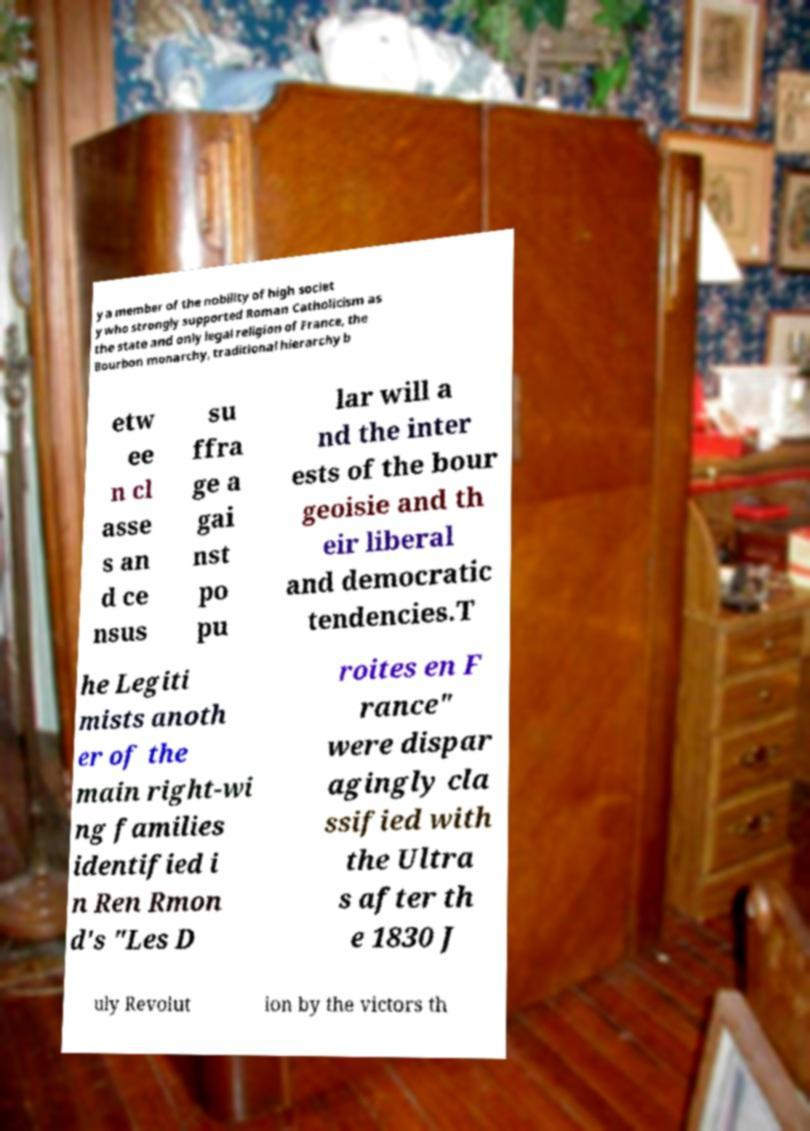Can you accurately transcribe the text from the provided image for me? y a member of the nobility of high societ y who strongly supported Roman Catholicism as the state and only legal religion of France, the Bourbon monarchy, traditional hierarchy b etw ee n cl asse s an d ce nsus su ffra ge a gai nst po pu lar will a nd the inter ests of the bour geoisie and th eir liberal and democratic tendencies.T he Legiti mists anoth er of the main right-wi ng families identified i n Ren Rmon d's "Les D roites en F rance" were dispar agingly cla ssified with the Ultra s after th e 1830 J uly Revolut ion by the victors th 